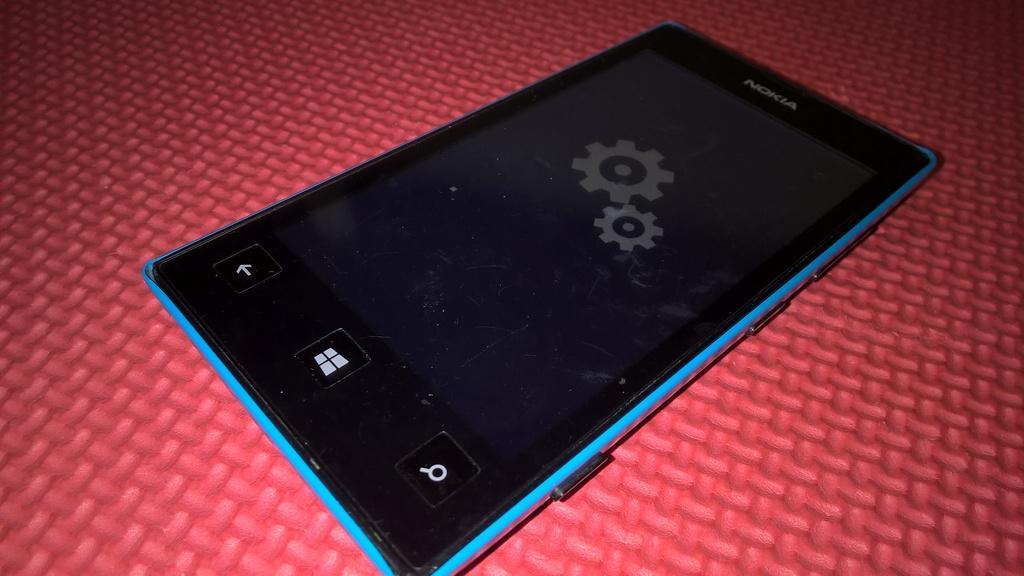What electronic device is visible in the image? There is a tablet in the image. Where is the tablet located? The tablet is placed on a table. What type of mine is depicted in the image? There is no mine present in the image; it features a tablet placed on a table. What type of door can be seen in the image? There is no door present in the image; it features a tablet placed on a table. 